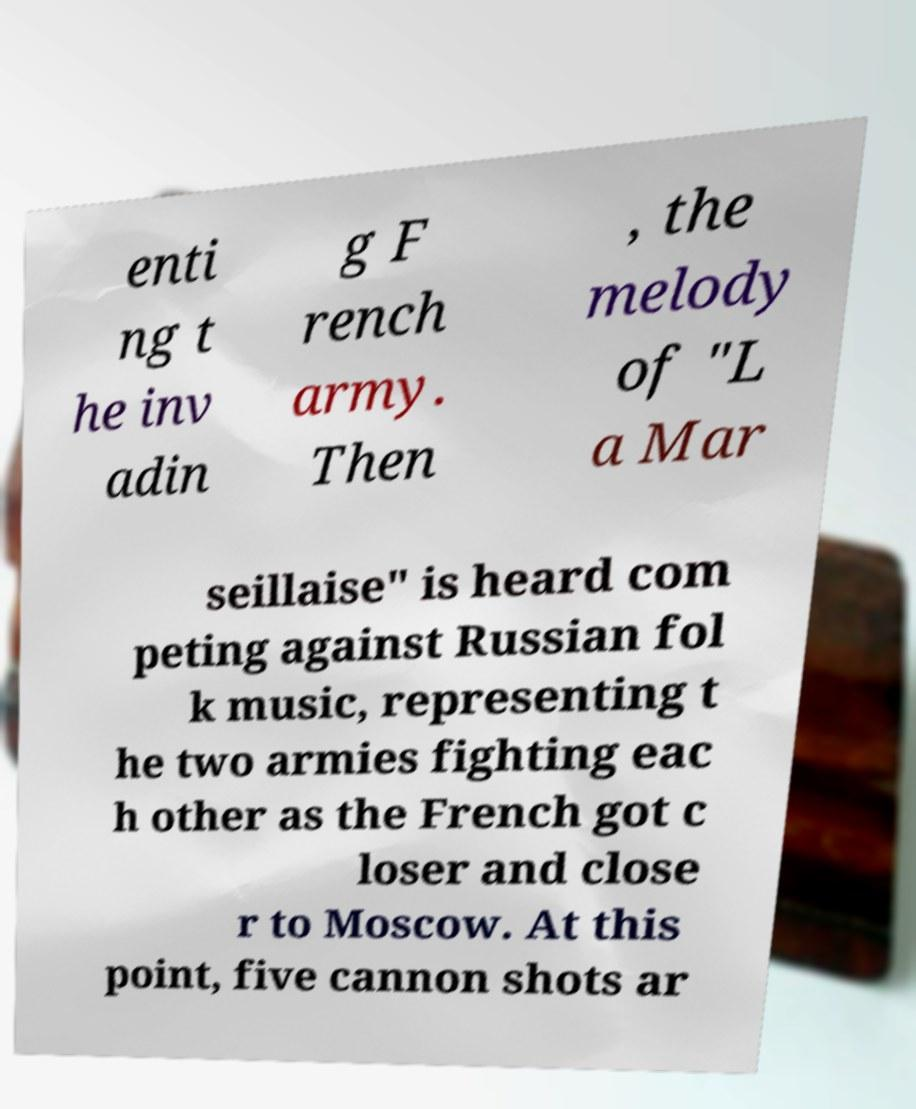Please read and relay the text visible in this image. What does it say? enti ng t he inv adin g F rench army. Then , the melody of "L a Mar seillaise" is heard com peting against Russian fol k music, representing t he two armies fighting eac h other as the French got c loser and close r to Moscow. At this point, five cannon shots ar 